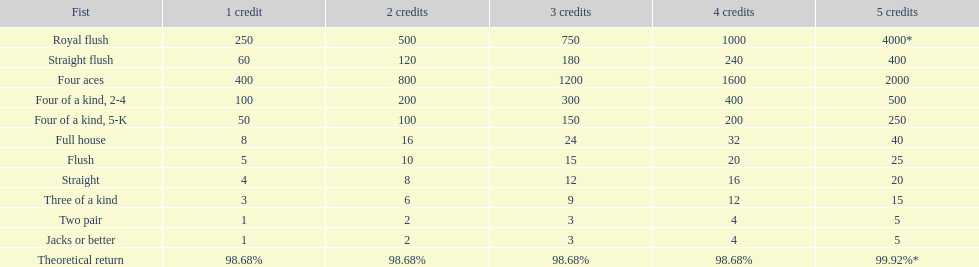Which variation of four of a kind offers the highest chances of victory? Four of a kind, 2-4. 